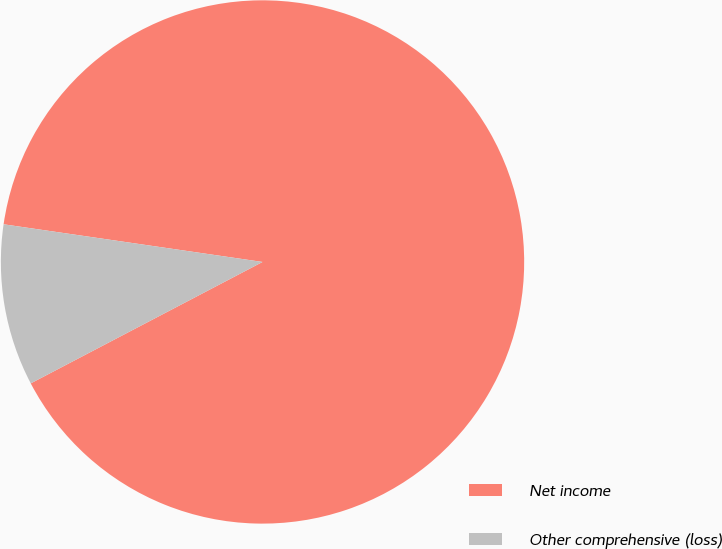Convert chart to OTSL. <chart><loc_0><loc_0><loc_500><loc_500><pie_chart><fcel>Net income<fcel>Other comprehensive (loss)<nl><fcel>90.02%<fcel>9.98%<nl></chart> 